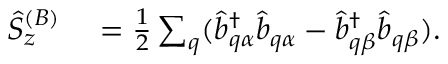<formula> <loc_0><loc_0><loc_500><loc_500>\begin{array} { r l } { \hat { S } _ { z } ^ { ( B ) } } & = \frac { 1 } { 2 } \sum _ { q } ( \hat { b } _ { q \alpha } ^ { \dagger } \hat { b } _ { q \alpha } - \hat { b } _ { q \beta } ^ { \dagger } \hat { b } _ { q \beta } ) . } \end{array}</formula> 